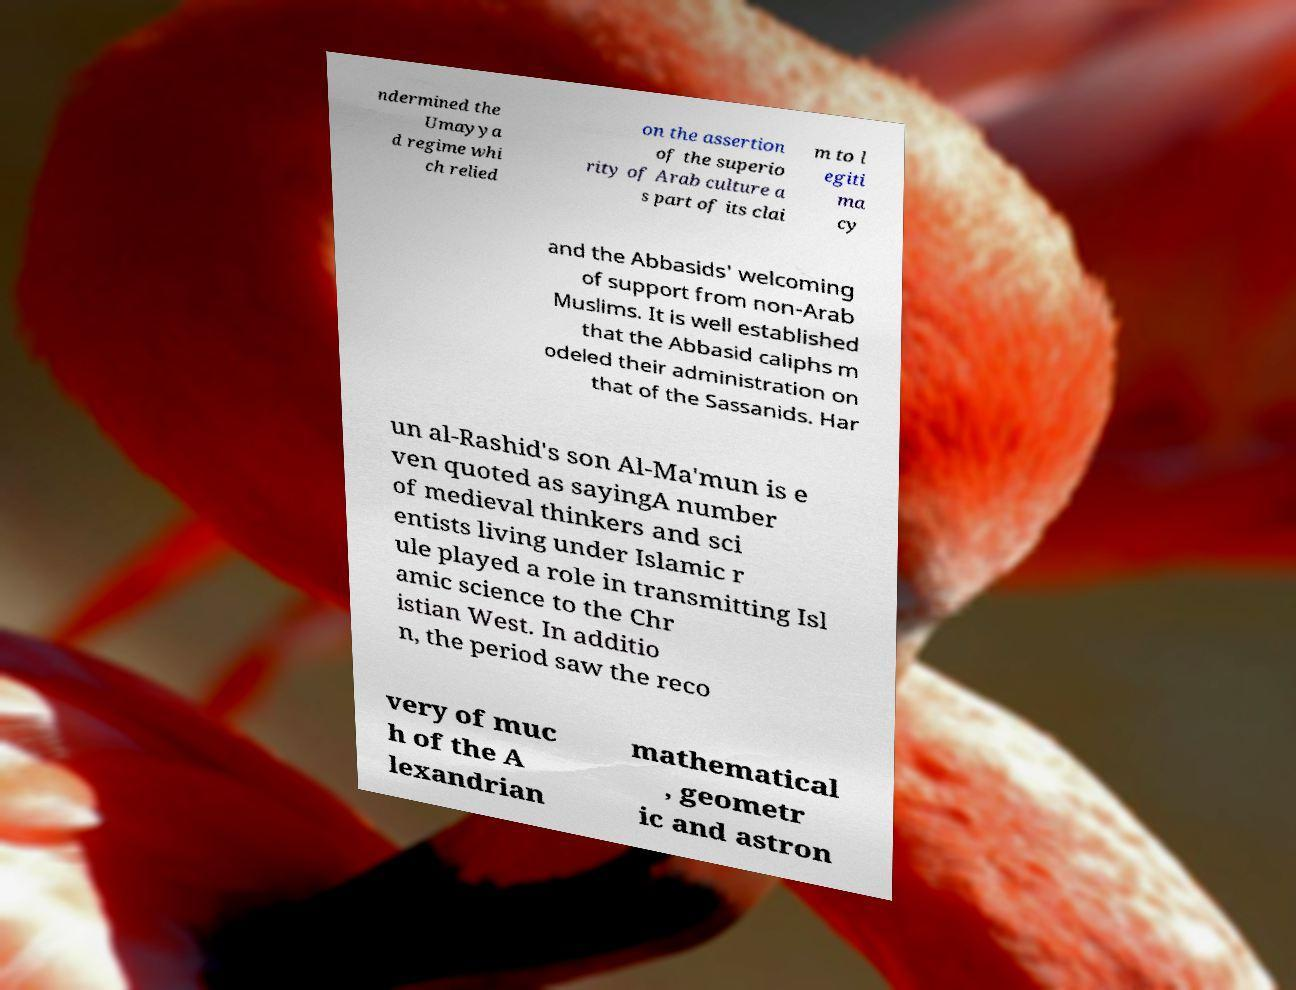Could you assist in decoding the text presented in this image and type it out clearly? ndermined the Umayya d regime whi ch relied on the assertion of the superio rity of Arab culture a s part of its clai m to l egiti ma cy and the Abbasids' welcoming of support from non-Arab Muslims. It is well established that the Abbasid caliphs m odeled their administration on that of the Sassanids. Har un al-Rashid's son Al-Ma'mun is e ven quoted as sayingA number of medieval thinkers and sci entists living under Islamic r ule played a role in transmitting Isl amic science to the Chr istian West. In additio n, the period saw the reco very of muc h of the A lexandrian mathematical , geometr ic and astron 